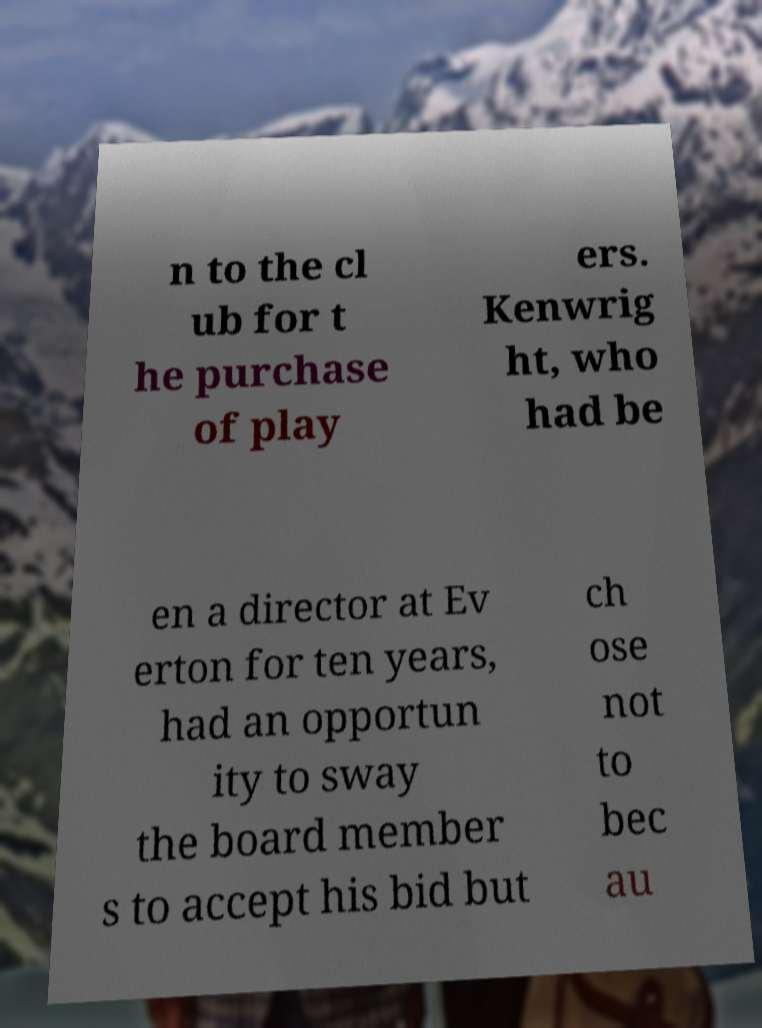Could you assist in decoding the text presented in this image and type it out clearly? n to the cl ub for t he purchase of play ers. Kenwrig ht, who had be en a director at Ev erton for ten years, had an opportun ity to sway the board member s to accept his bid but ch ose not to bec au 